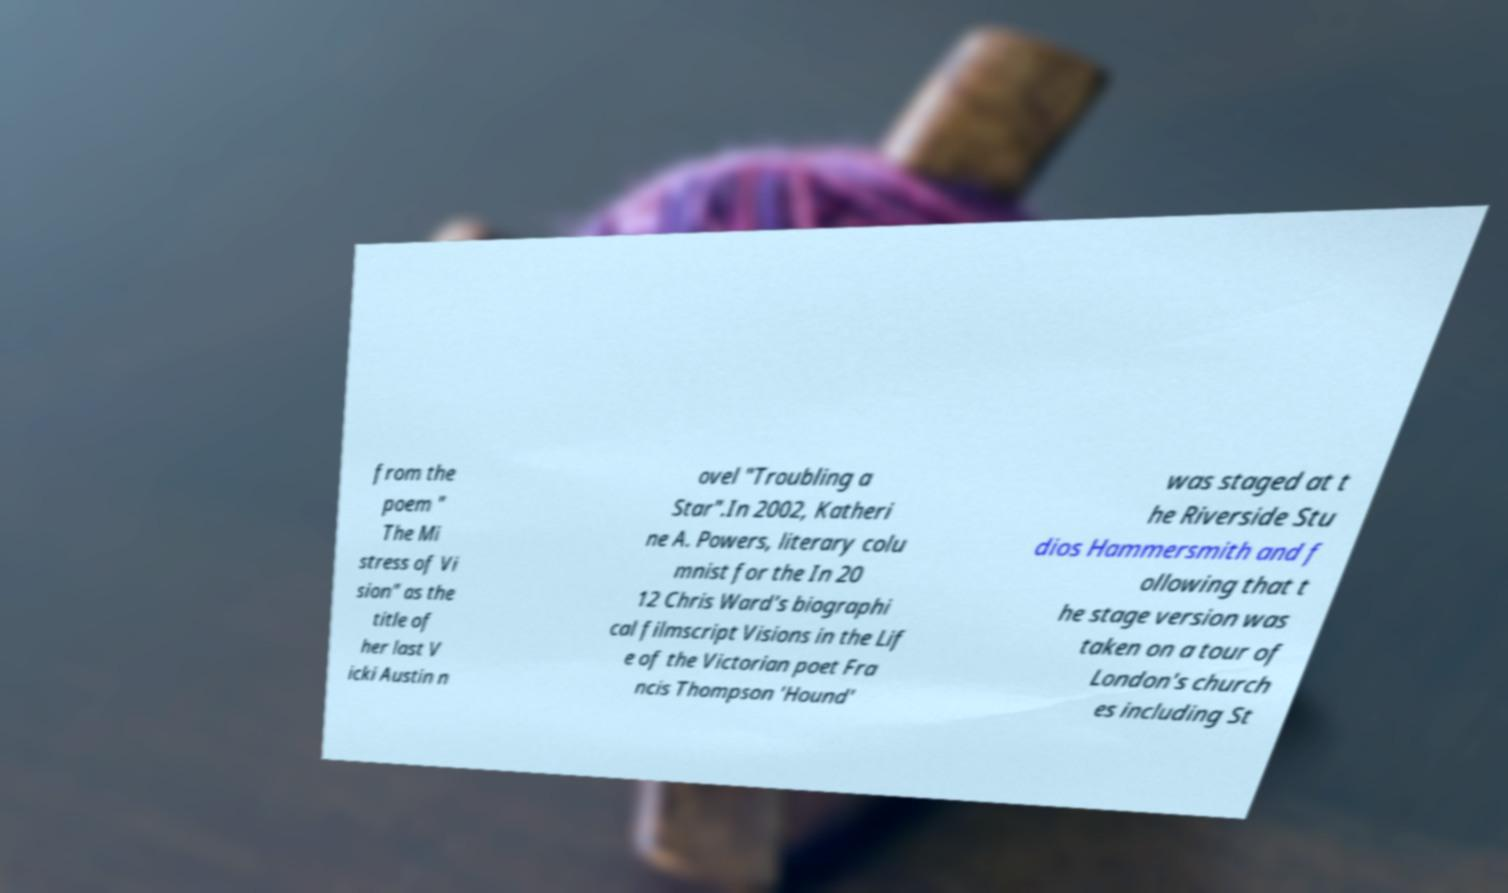Could you extract and type out the text from this image? from the poem " The Mi stress of Vi sion" as the title of her last V icki Austin n ovel "Troubling a Star".In 2002, Katheri ne A. Powers, literary colu mnist for the In 20 12 Chris Ward's biographi cal filmscript Visions in the Lif e of the Victorian poet Fra ncis Thompson 'Hound' was staged at t he Riverside Stu dios Hammersmith and f ollowing that t he stage version was taken on a tour of London's church es including St 